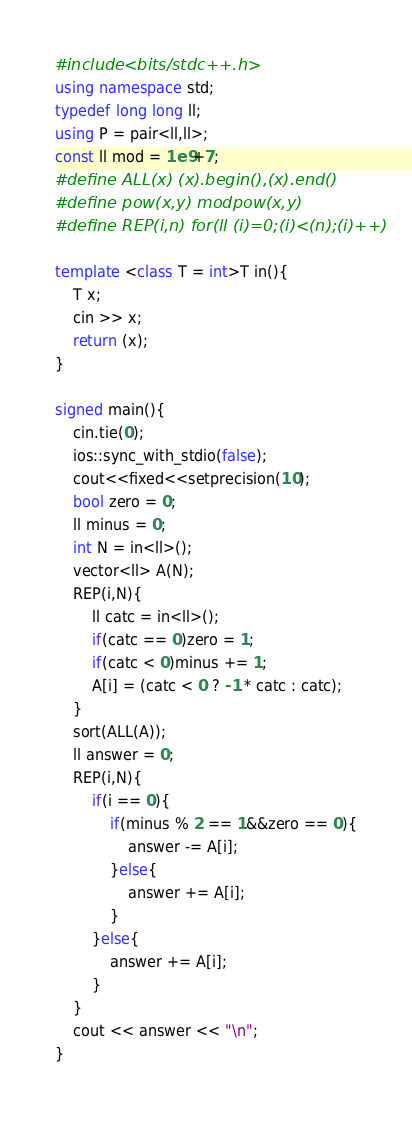<code> <loc_0><loc_0><loc_500><loc_500><_C++_>#include <bits/stdc++.h>
using namespace std;
typedef long long ll;
using P = pair<ll,ll>;
const ll mod = 1e9+7;
#define ALL(x) (x).begin(),(x).end()
#define pow(x,y) modpow(x,y)
#define REP(i,n) for(ll (i)=0;(i)<(n);(i)++)

template <class T = int>T in(){
    T x;
    cin >> x;
    return (x);
}

signed main(){
    cin.tie(0);
    ios::sync_with_stdio(false);
    cout<<fixed<<setprecision(10);
    bool zero = 0;
    ll minus = 0;
    int N = in<ll>();
    vector<ll> A(N);
    REP(i,N){
        ll catc = in<ll>();
        if(catc == 0)zero = 1;
        if(catc < 0)minus += 1;
        A[i] = (catc < 0 ? -1 * catc : catc);
    }
    sort(ALL(A));
    ll answer = 0;
    REP(i,N){
        if(i == 0){
            if(minus % 2 == 1&&zero == 0){
                answer -= A[i];
            }else{
                answer += A[i];
            }
        }else{
            answer += A[i];
        }
    }
    cout << answer << "\n";
}</code> 